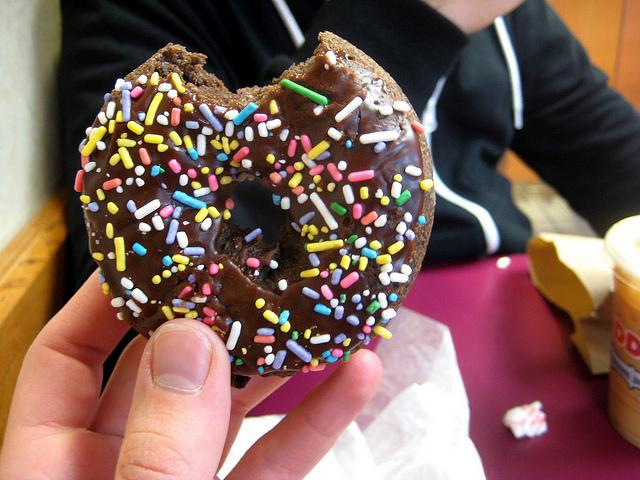Is this an edible donut?
Answer briefly. Yes. What are the colorful things on the donut?
Quick response, please. Sprinkles. Did the person holding the donut paint their fingernails?
Concise answer only. No. What kind of doughnut?
Give a very brief answer. Chocolate. Is this donut smiling?
Quick response, please. No. 